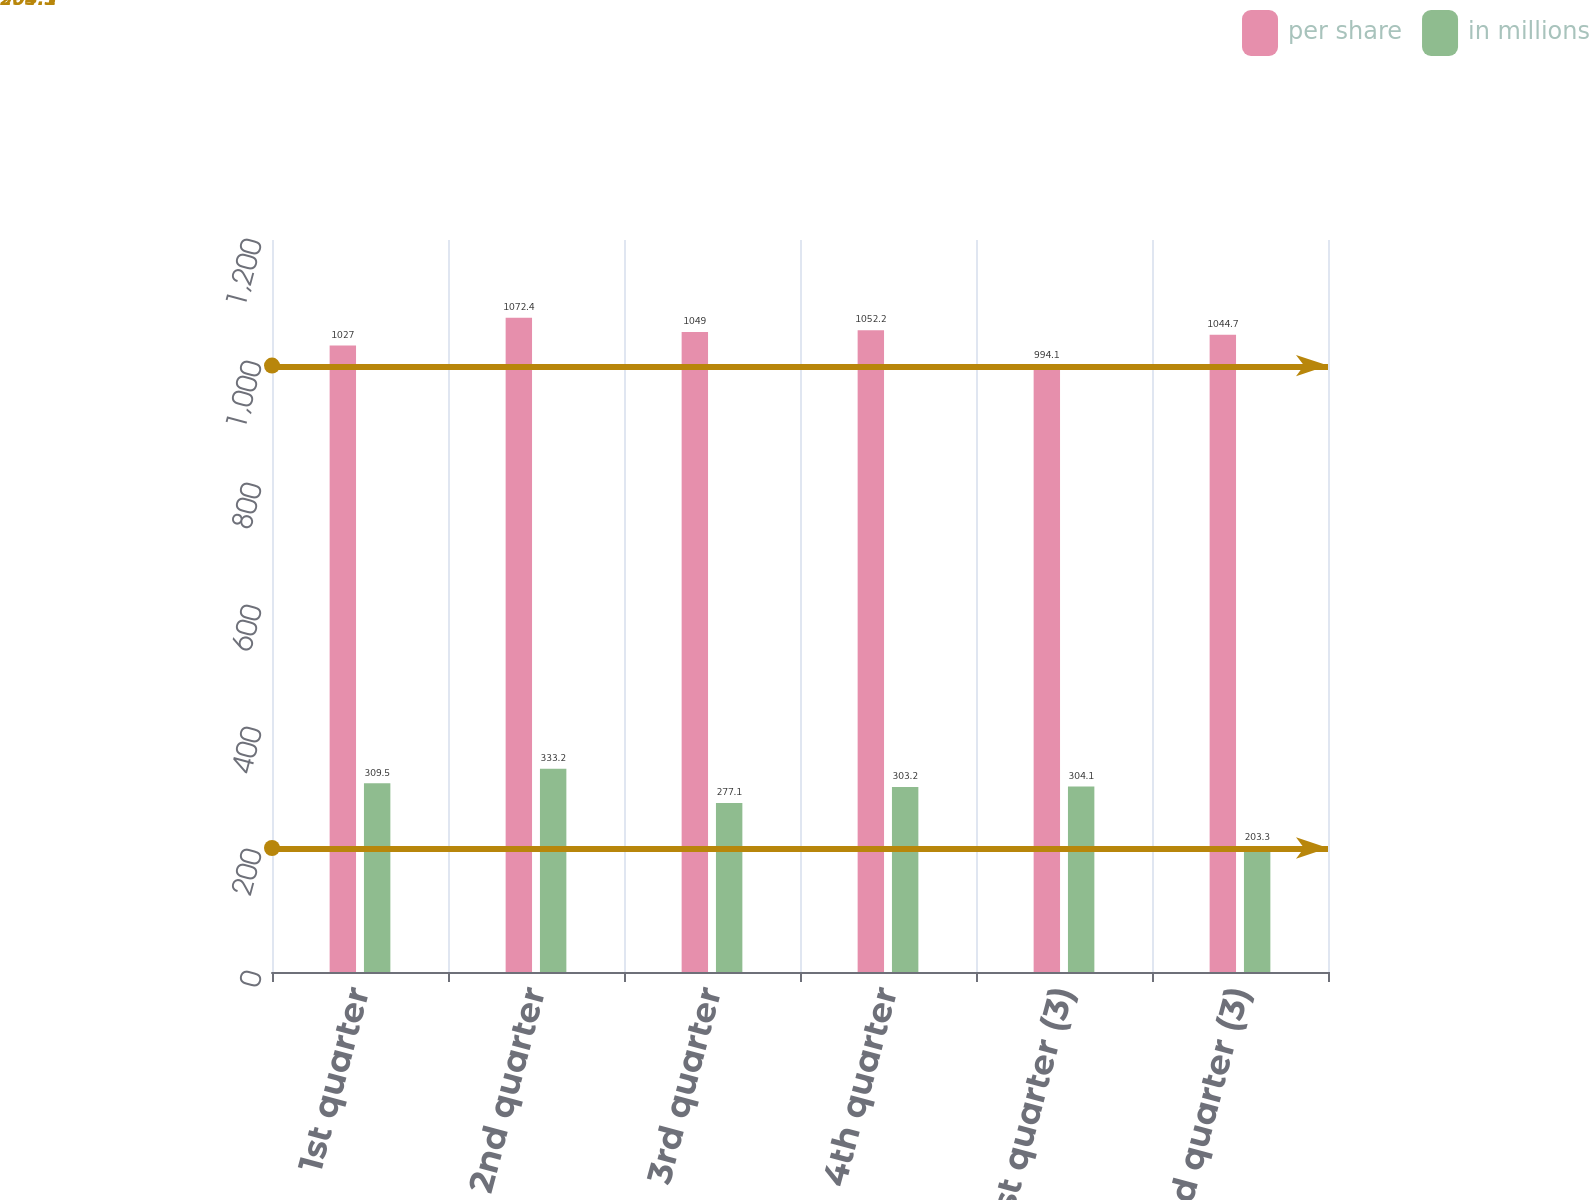<chart> <loc_0><loc_0><loc_500><loc_500><stacked_bar_chart><ecel><fcel>1st quarter<fcel>2nd quarter<fcel>3rd quarter<fcel>4th quarter<fcel>1st quarter (3)<fcel>2nd quarter (3)<nl><fcel>per share<fcel>1027<fcel>1072.4<fcel>1049<fcel>1052.2<fcel>994.1<fcel>1044.7<nl><fcel>in millions<fcel>309.5<fcel>333.2<fcel>277.1<fcel>303.2<fcel>304.1<fcel>203.3<nl></chart> 